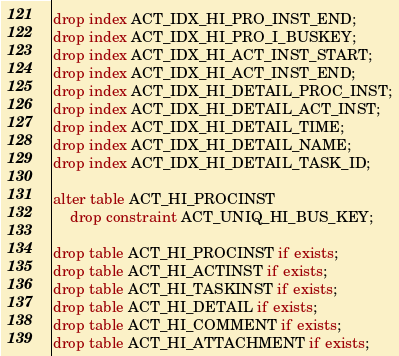<code> <loc_0><loc_0><loc_500><loc_500><_SQL_>drop index ACT_IDX_HI_PRO_INST_END;
drop index ACT_IDX_HI_PRO_I_BUSKEY;
drop index ACT_IDX_HI_ACT_INST_START;
drop index ACT_IDX_HI_ACT_INST_END;
drop index ACT_IDX_HI_DETAIL_PROC_INST;
drop index ACT_IDX_HI_DETAIL_ACT_INST;
drop index ACT_IDX_HI_DETAIL_TIME;
drop index ACT_IDX_HI_DETAIL_NAME;
drop index ACT_IDX_HI_DETAIL_TASK_ID;

alter table ACT_HI_PROCINST
    drop constraint ACT_UNIQ_HI_BUS_KEY;
    
drop table ACT_HI_PROCINST if exists;
drop table ACT_HI_ACTINST if exists;
drop table ACT_HI_TASKINST if exists;
drop table ACT_HI_DETAIL if exists;
drop table ACT_HI_COMMENT if exists;
drop table ACT_HI_ATTACHMENT if exists;
</code> 